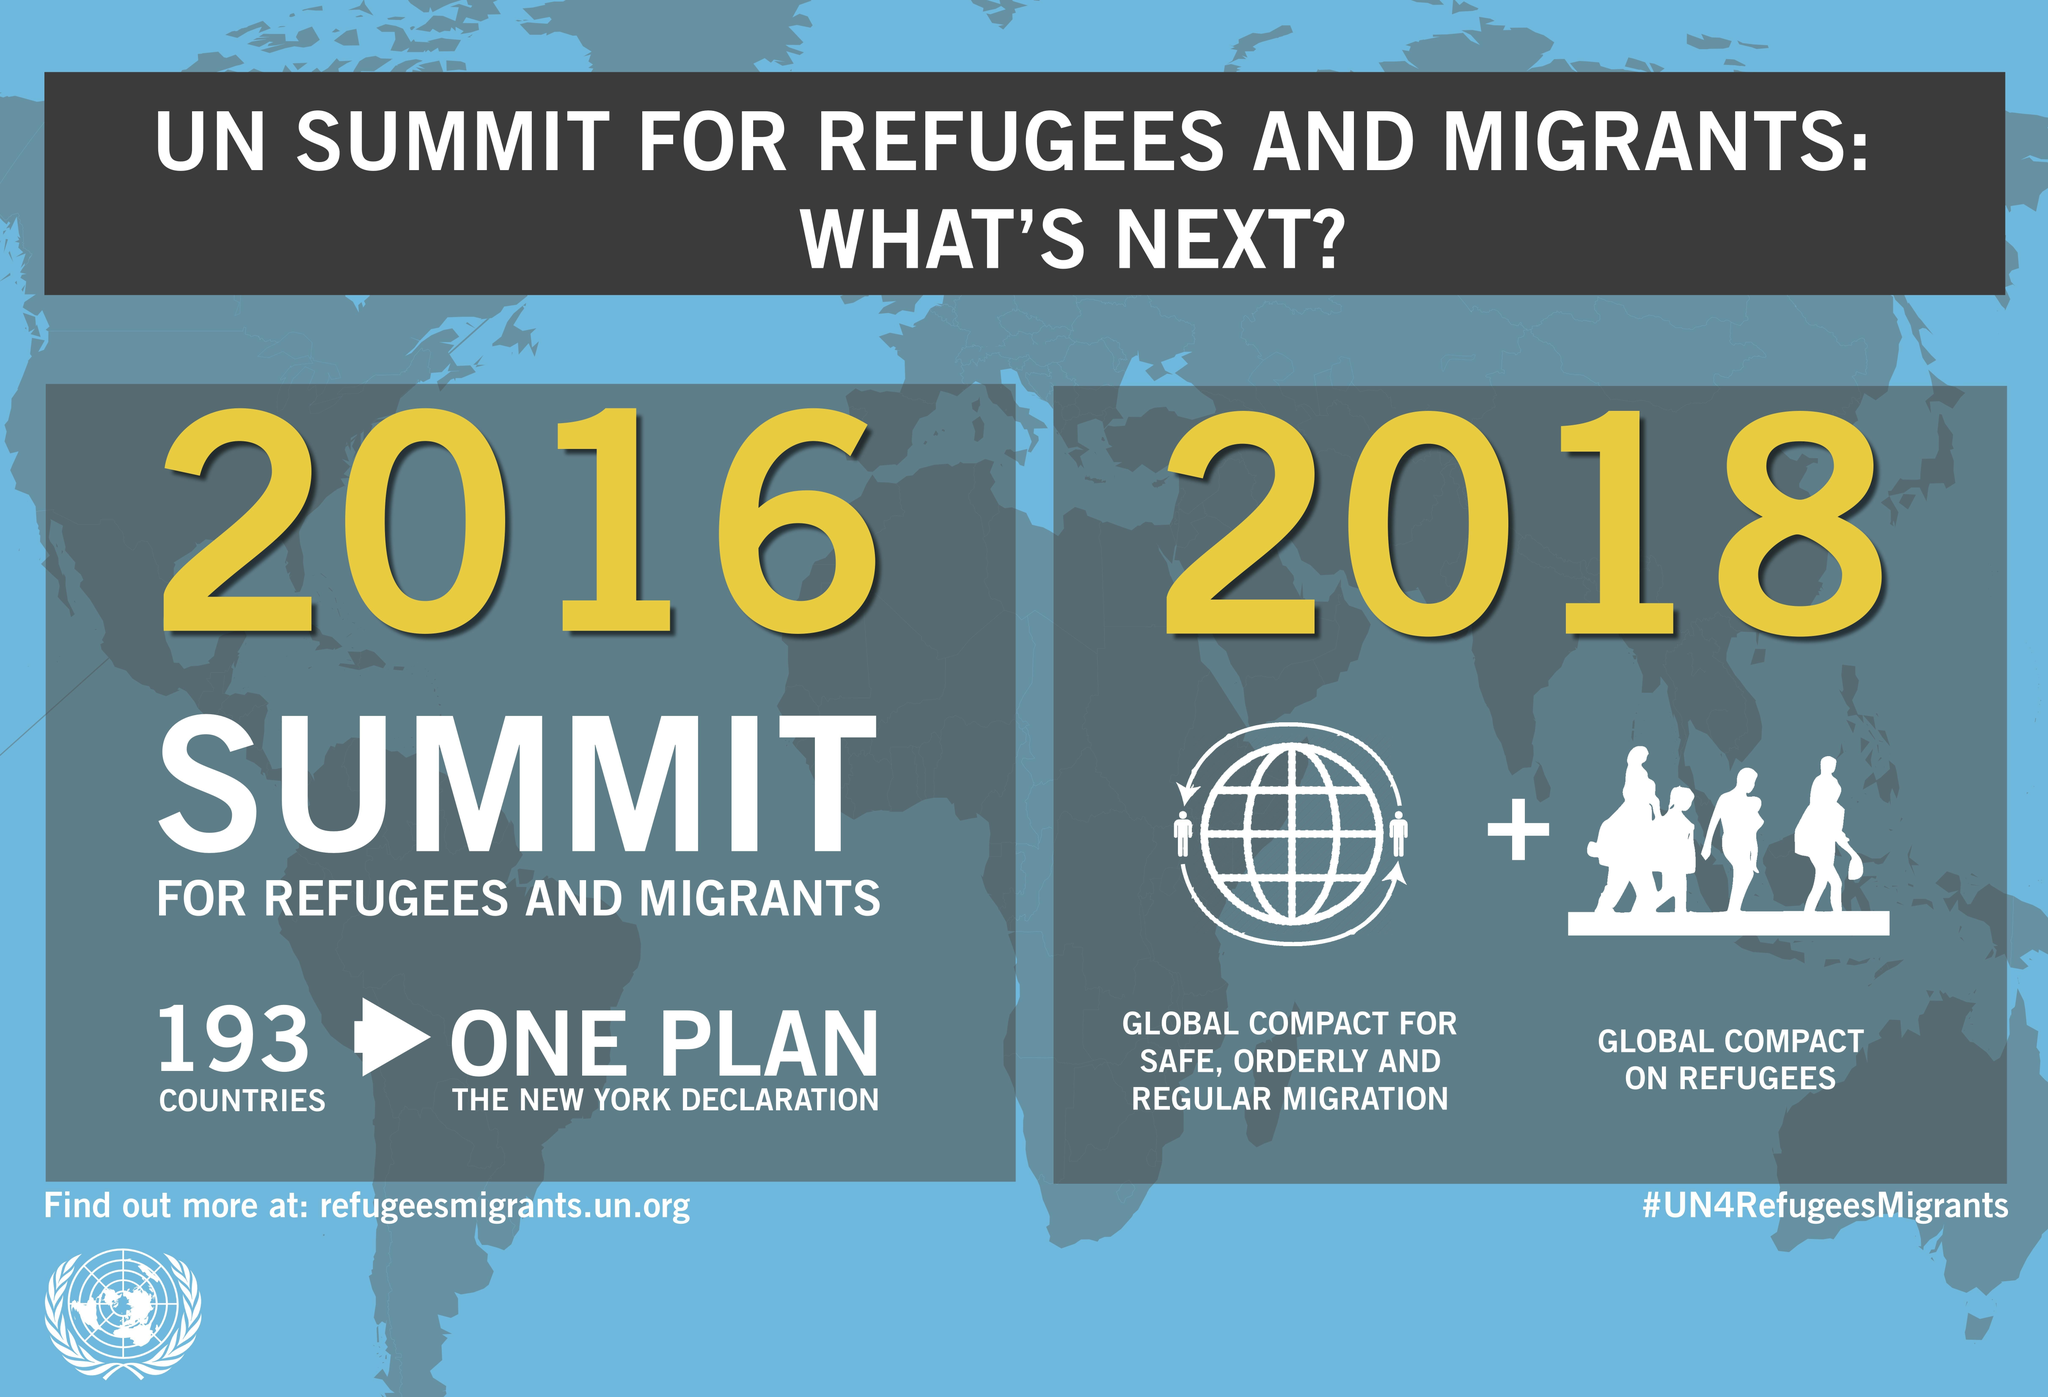what is the other action planned for 2018 in addition to global compact on refugees
Answer the question with a short phrase. global compact for safe, orderly and regular migration which are the 2 years mentioned 2016, 2018 how many countries participated in the summit 193 